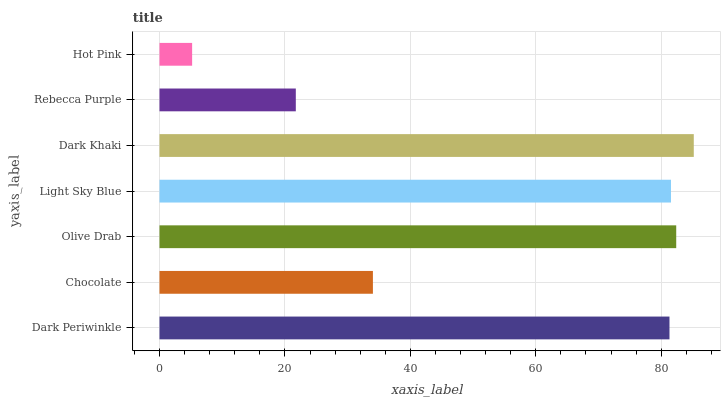Is Hot Pink the minimum?
Answer yes or no. Yes. Is Dark Khaki the maximum?
Answer yes or no. Yes. Is Chocolate the minimum?
Answer yes or no. No. Is Chocolate the maximum?
Answer yes or no. No. Is Dark Periwinkle greater than Chocolate?
Answer yes or no. Yes. Is Chocolate less than Dark Periwinkle?
Answer yes or no. Yes. Is Chocolate greater than Dark Periwinkle?
Answer yes or no. No. Is Dark Periwinkle less than Chocolate?
Answer yes or no. No. Is Dark Periwinkle the high median?
Answer yes or no. Yes. Is Dark Periwinkle the low median?
Answer yes or no. Yes. Is Olive Drab the high median?
Answer yes or no. No. Is Olive Drab the low median?
Answer yes or no. No. 